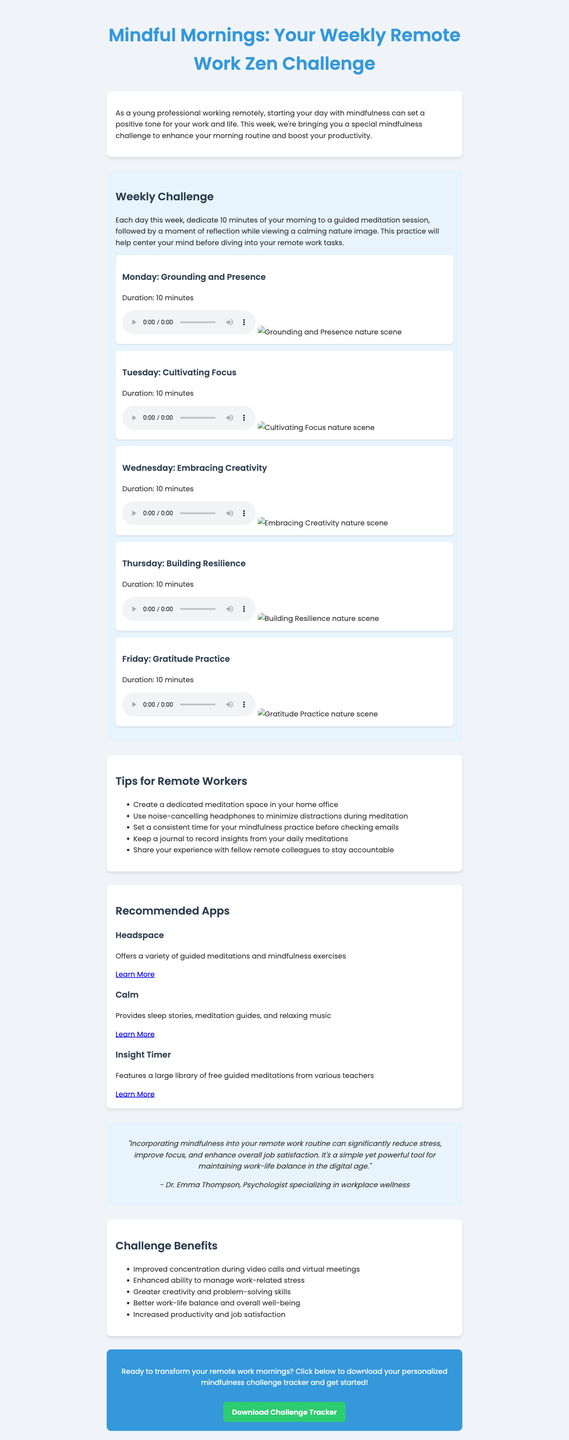What is the title of the newsletter? The title of the newsletter is mentioned at the beginning of the document.
Answer: Mindful Mornings: Your Weekly Remote Work Zen Challenge How many days does the mindfulness challenge span? The challenge covers a specific number of days as described in the document, which is outlined in the challenge description.
Answer: 5 days What is the theme for Wednesday's meditation? The themes for each day's meditation are listed in the daily meditations section of the document.
Answer: Embracing Creativity Which app is recommended for guided meditations? The recommended apps section lists several apps, including one specifically for guided meditations.
Answer: Headspace What is one benefit of the mindfulness challenge? Benefits of the challenge are provided in the benefits section, listing specific positive outcomes.
Answer: Improved concentration during video calls and virtual meetings What is the duration of each guided meditation? The duration of the meditations is mentioned alongside the daily meditations in the document.
Answer: 10 minutes Who provided the expert quote in the newsletter? The author of the expert quote is noted at the end of the quote section in the document.
Answer: Dr. Emma Thompson What do the tips section suggest for meditation space? The tips for remote workers provide various suggestions for creating an effective meditation environment.
Answer: Create a dedicated meditation space in your home office What is the color of the call-to-action button? The color of the button is specified in the styling description of the call-to-action section of the document.
Answer: Green 